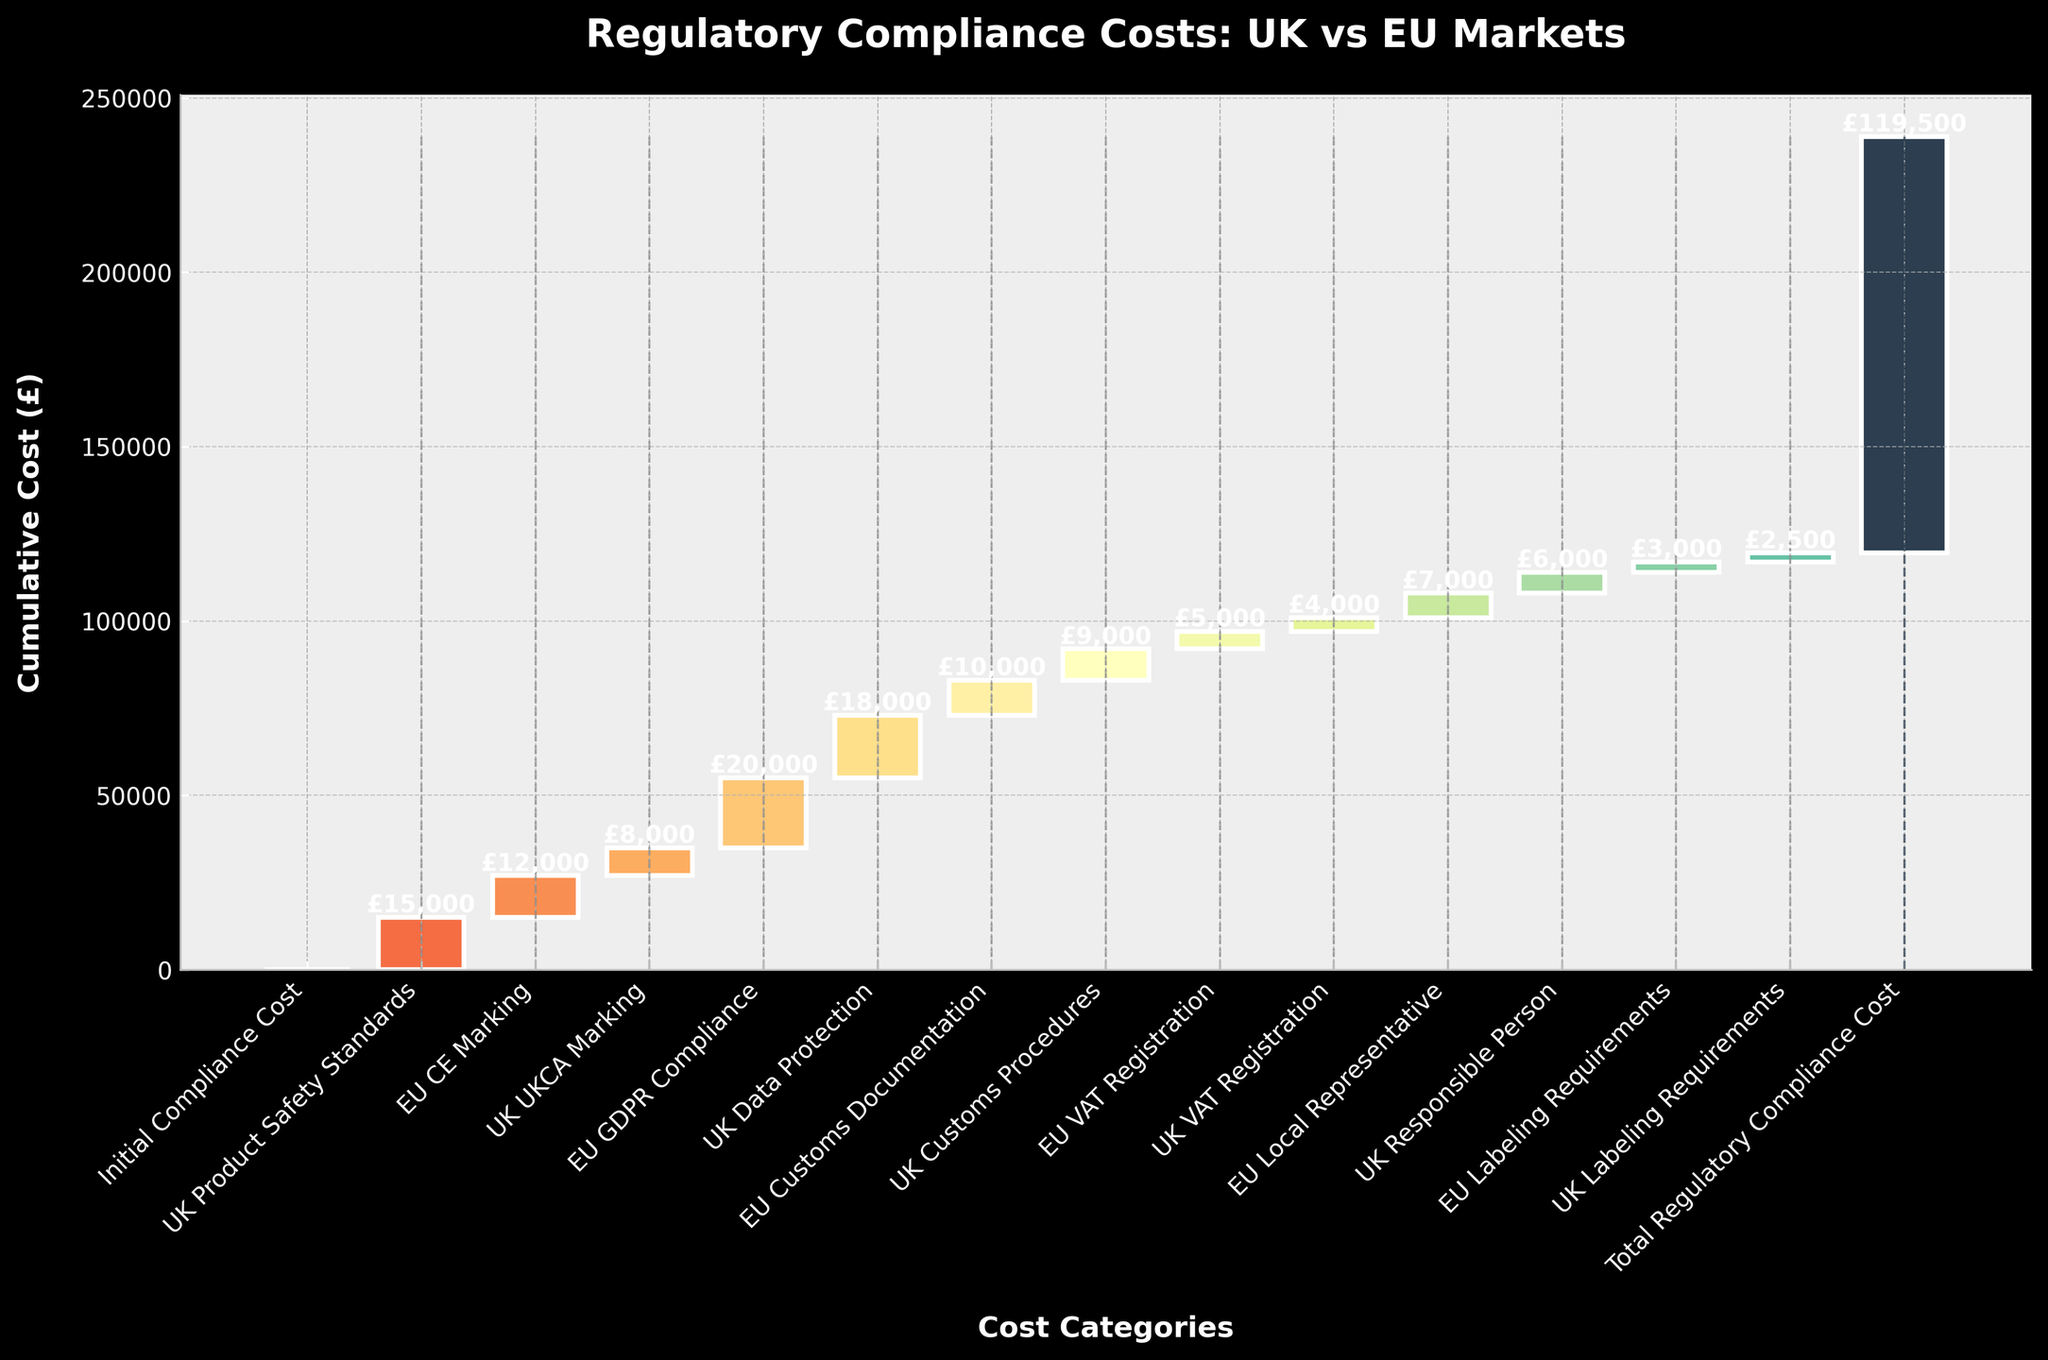What is the title of the chart? The title of the chart is displayed at the top of the figure. It should summarize the focus of the chart.
Answer: Regulatory Compliance Costs: UK vs EU Markets What is the cumulative cost for EU CE Marking? The cumulative cost for EU CE Marking is the value associated with the category "EU CE Marking" displayed on the chart.
Answer: £12,000 How does the cost of UK Product Safety Standards compare to UK UKCA Marking? By observing the height of the bars corresponding to "UK Product Safety Standards" and "UK UKCA Marking," we can see that the cost of UK Product Safety Standards is higher.
Answer: UK Product Safety Standards: £15,000, UK UKCA Marking: £8,000 Which category has the highest individual compliance cost? Identifying the tallest single bar that isn't the initial or total cumulative cost will determine which category has the highest individual cost.
Answer: EU GDPR Compliance What is the total compliance cost for the UK as displayed? Sum all the values associated with UK categories. £15,000 (Safety Standards) + £8,000 (UKCA Marking) + £18,000 (Data Protection) + £9,000 (Customs Procedures) + £4,000 (VAT Registration) + £6,000 (Responsible Person) + £2,500 (Labeling Requirements)
Answer: £62,500 What is the total compliance cost for the EU as displayed? Sum all the values associated with EU categories. £12,000 (CE Marking) + £20,000 (GDPR Compliance) + £10,000 (Customs Documentation) + £5,000 (VAT Registration) + £7,000 (Local Representative) + £3,000 (Labeling Requirements)
Answer: £57,000 How does the cumulative compliance cost of EU Customs Documentation compare to UK Customs Procedures? By comparing the heights of the bars corresponding to "EU Customs Documentation" and "UK Customs Procedures," we can determine their values are £10,000 and £9,000 respectively.
Answer: EU Customs Documentation: £10,000, UK Customs Procedures: £9,000 Which component has a higher cost: UK Data Protection or EU GDPR Compliance? Compare the bars corresponding to "UK Data Protection" and "EU GDPR Compliance." EU GDPR Compliance is higher.
Answer: EU GDPR Compliance How is the cumulative cost illustrated in the chart? The waterfall chart uses bars of different colors to show how the costs add up cumulatively, with each additional category increasing the total height of the bar until reaching "Total Regulatory Compliance Cost."
Answer: Through cumulative addition of component costs What is the total displayed regulatory compliance cost in the chart? This is highlighted at the end of the cumulative bars and labeled as "Total Regulatory Compliance Cost." The value is displayed at the top of the final bar.
Answer: £119,500 